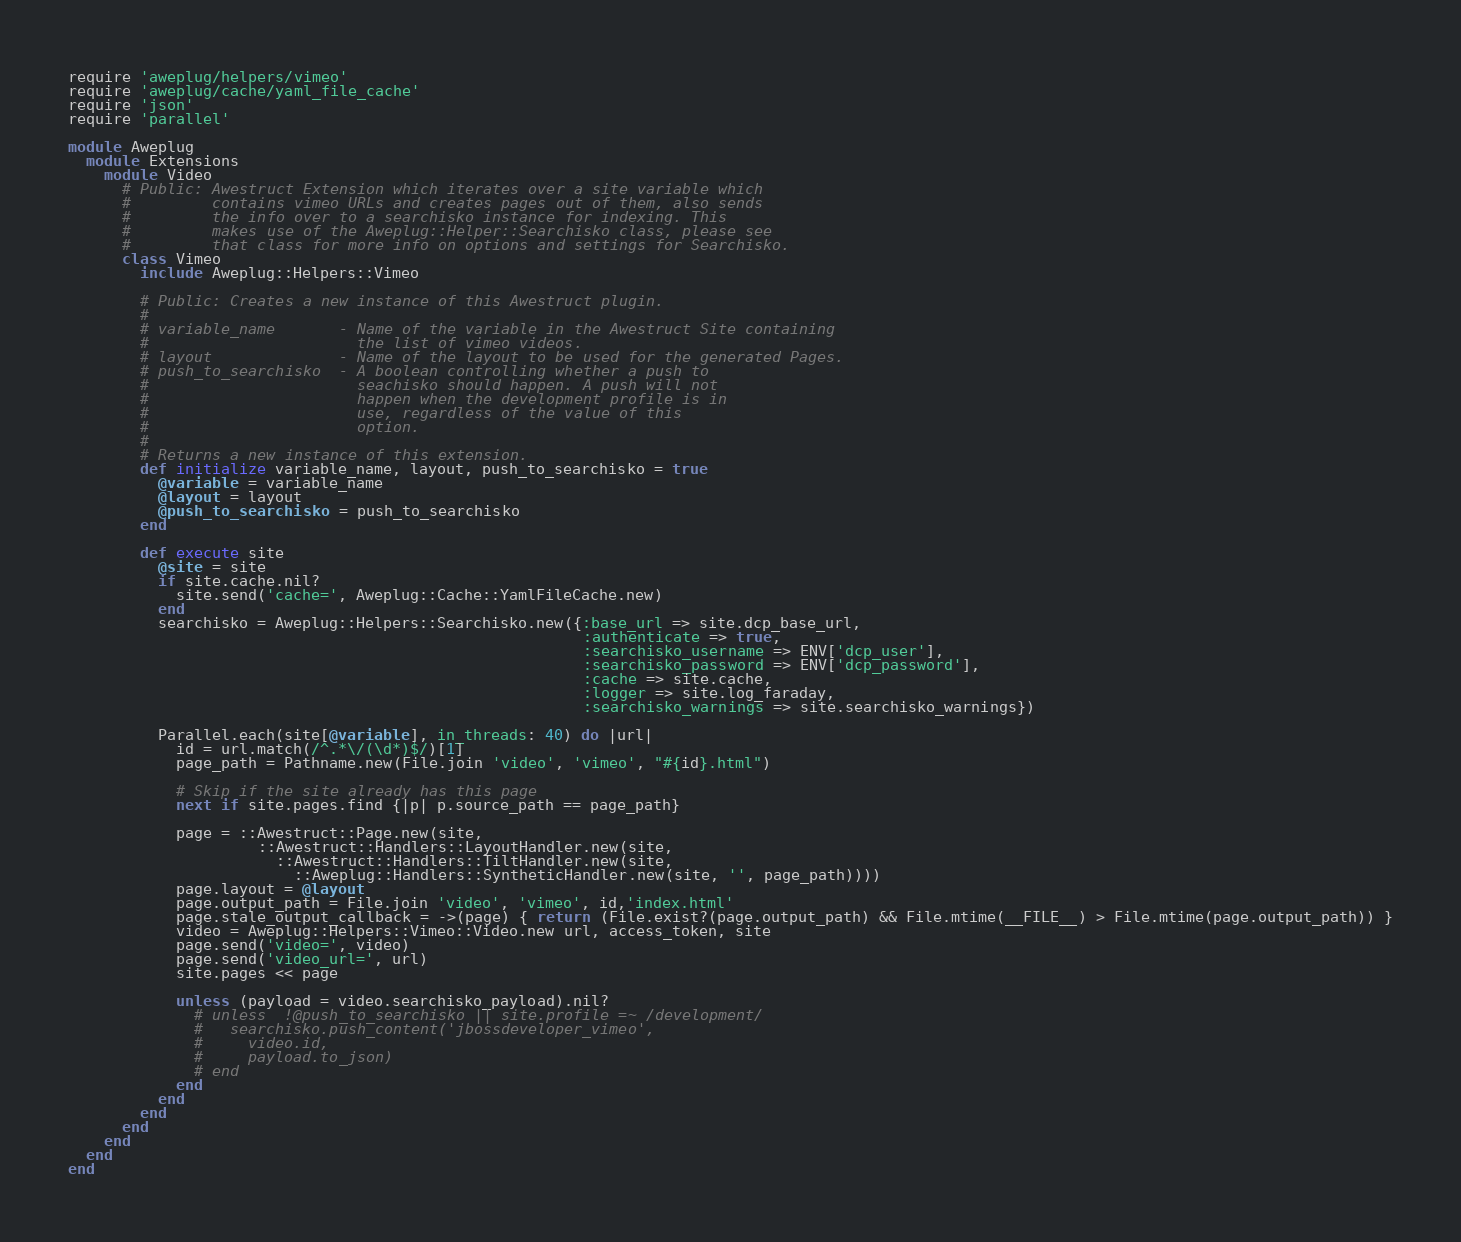Convert code to text. <code><loc_0><loc_0><loc_500><loc_500><_Ruby_>require 'aweplug/helpers/vimeo'
require 'aweplug/cache/yaml_file_cache'
require 'json'
require 'parallel'

module Aweplug
  module Extensions
    module Video
      # Public: Awestruct Extension which iterates over a site variable which 
      #         contains vimeo URLs and creates pages out of them, also sends 
      #         the info over to a searchisko instance for indexing. This 
      #         makes use of the Aweplug::Helper::Searchisko class, please see 
      #         that class for more info on options and settings for Searchisko.  
      class Vimeo
        include Aweplug::Helpers::Vimeo

        # Public: Creates a new instance of this Awestruct plugin.
        #
        # variable_name       - Name of the variable in the Awestruct Site containing
        #                       the list of vimeo videos.
        # layout              - Name of the layout to be used for the generated Pages.
        # push_to_searchisko  - A boolean controlling whether a push to
        #                       seachisko should happen. A push will not
        #                       happen when the development profile is in
        #                       use, regardless of the value of this 
        #                       option.
        #
        # Returns a new instance of this extension.                
        def initialize variable_name, layout, push_to_searchisko = true
          @variable = variable_name
          @layout = layout
          @push_to_searchisko = push_to_searchisko
        end

        def execute site 
          @site = site
          if site.cache.nil?
            site.send('cache=', Aweplug::Cache::YamlFileCache.new)
          end
          searchisko = Aweplug::Helpers::Searchisko.new({:base_url => site.dcp_base_url, 
                                                         :authenticate => true, 
                                                         :searchisko_username => ENV['dcp_user'], 
                                                         :searchisko_password => ENV['dcp_password'], 
                                                         :cache => site.cache,
                                                         :logger => site.log_faraday,
                                                         :searchisko_warnings => site.searchisko_warnings})

          Parallel.each(site[@variable], in_threads: 40) do |url|
            id = url.match(/^.*\/(\d*)$/)[1] 
            page_path = Pathname.new(File.join 'video', 'vimeo', "#{id}.html")

            # Skip if the site already has this page
            next if site.pages.find {|p| p.source_path == page_path}

            page = ::Awestruct::Page.new(site,
                     ::Awestruct::Handlers::LayoutHandler.new(site,
                       ::Awestruct::Handlers::TiltHandler.new(site,
                         ::Aweplug::Handlers::SyntheticHandler.new(site, '', page_path))))
            page.layout = @layout
            page.output_path = File.join 'video', 'vimeo', id,'index.html'
            page.stale_output_callback = ->(page) { return (File.exist?(page.output_path) && File.mtime(__FILE__) > File.mtime(page.output_path)) }
            video = Aweplug::Helpers::Vimeo::Video.new url, access_token, site
            page.send('video=', video)
            page.send('video_url=', url)
            site.pages << page 
            
            unless (payload = video.searchisko_payload).nil?
              # unless  !@push_to_searchisko || site.profile =~ /development/
              #   searchisko.push_content('jbossdeveloper_vimeo', 
              #     video.id, 
              #     payload.to_json)
              # end 
            end
          end
        end
      end
    end
  end
end
</code> 